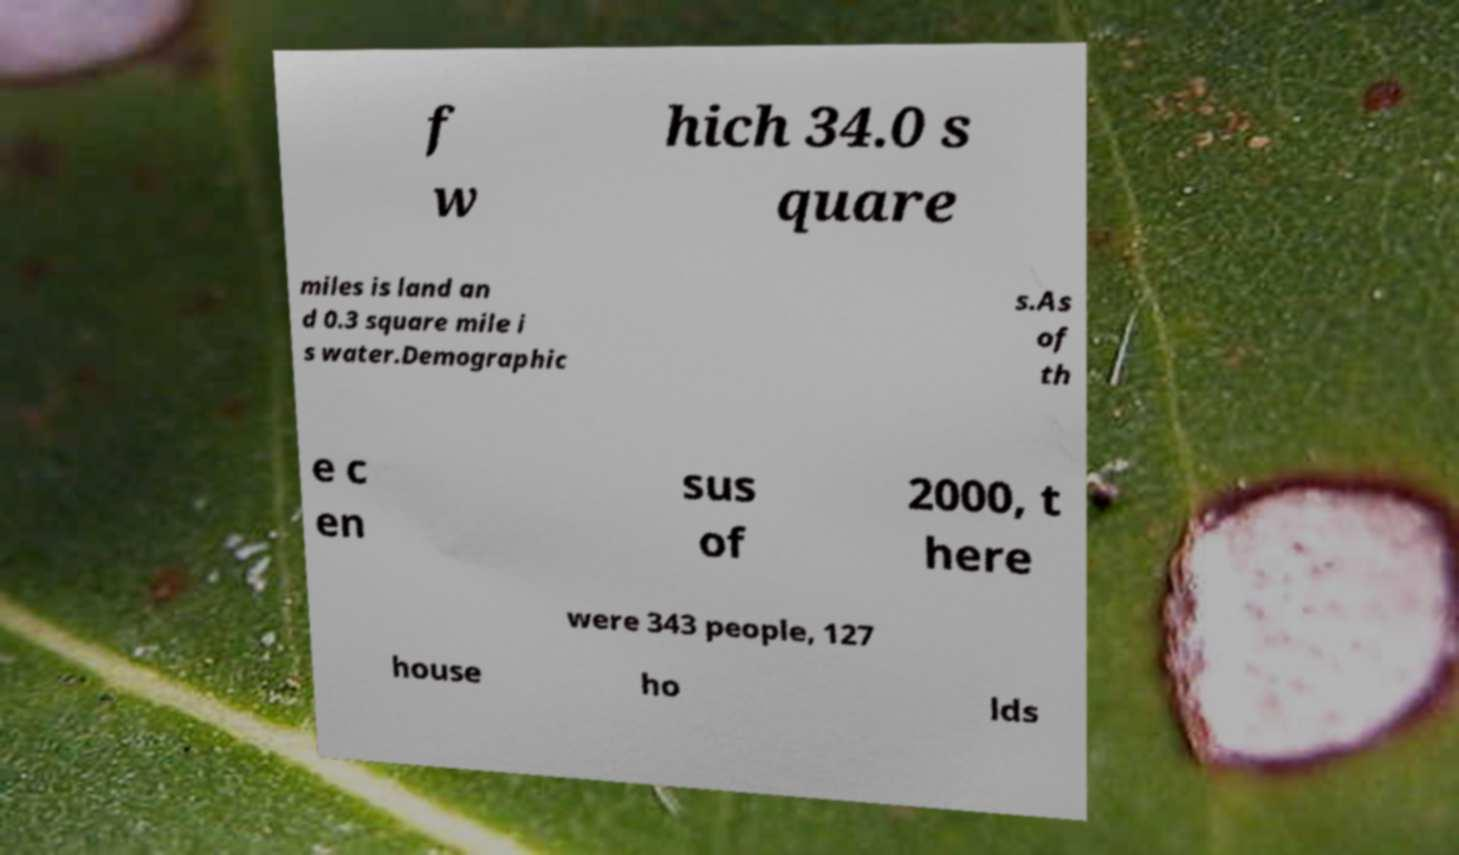There's text embedded in this image that I need extracted. Can you transcribe it verbatim? f w hich 34.0 s quare miles is land an d 0.3 square mile i s water.Demographic s.As of th e c en sus of 2000, t here were 343 people, 127 house ho lds 